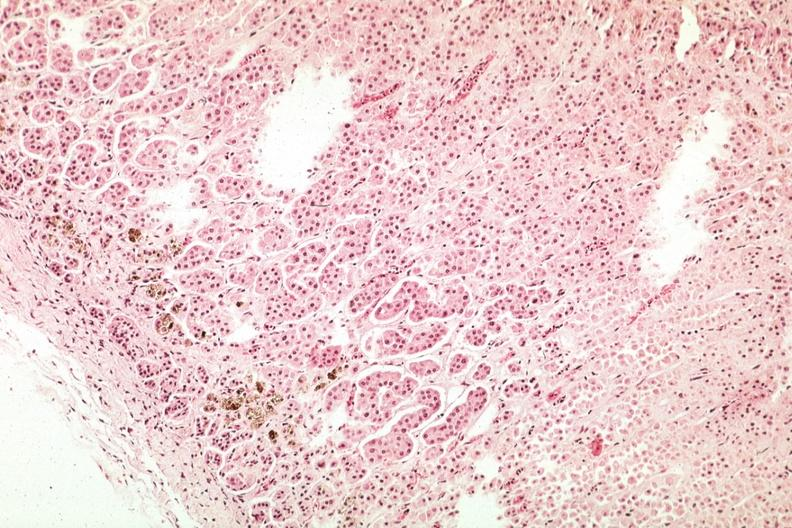where is this part in the figure?
Answer the question using a single word or phrase. Endocrine system 